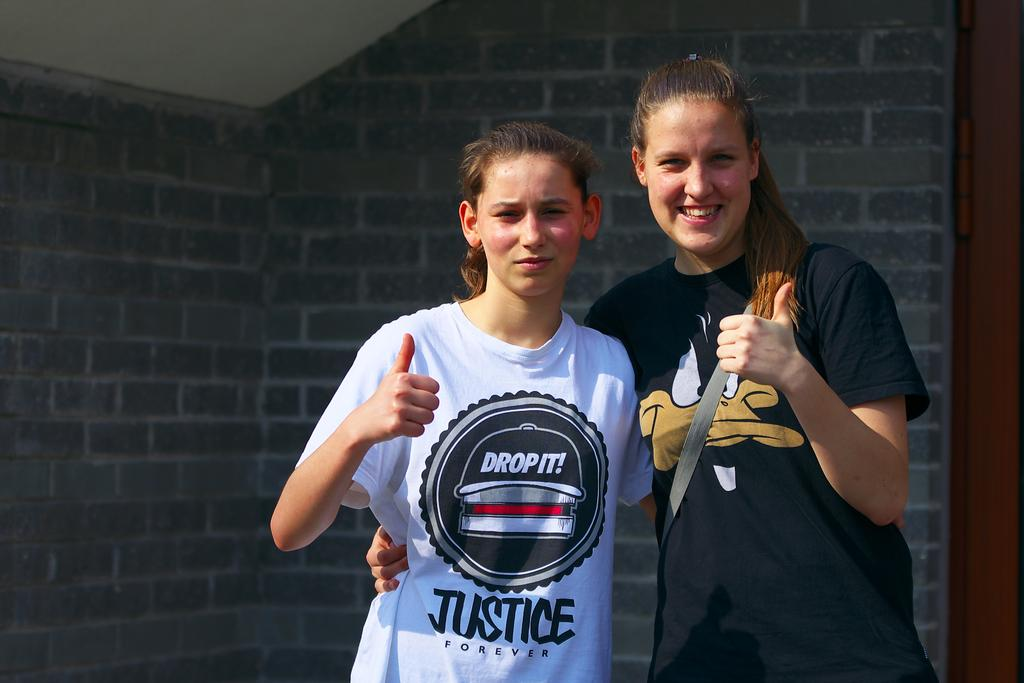<image>
Create a compact narrative representing the image presented. two girls give thumbs up signs while one wears a Drop It t-shirt 